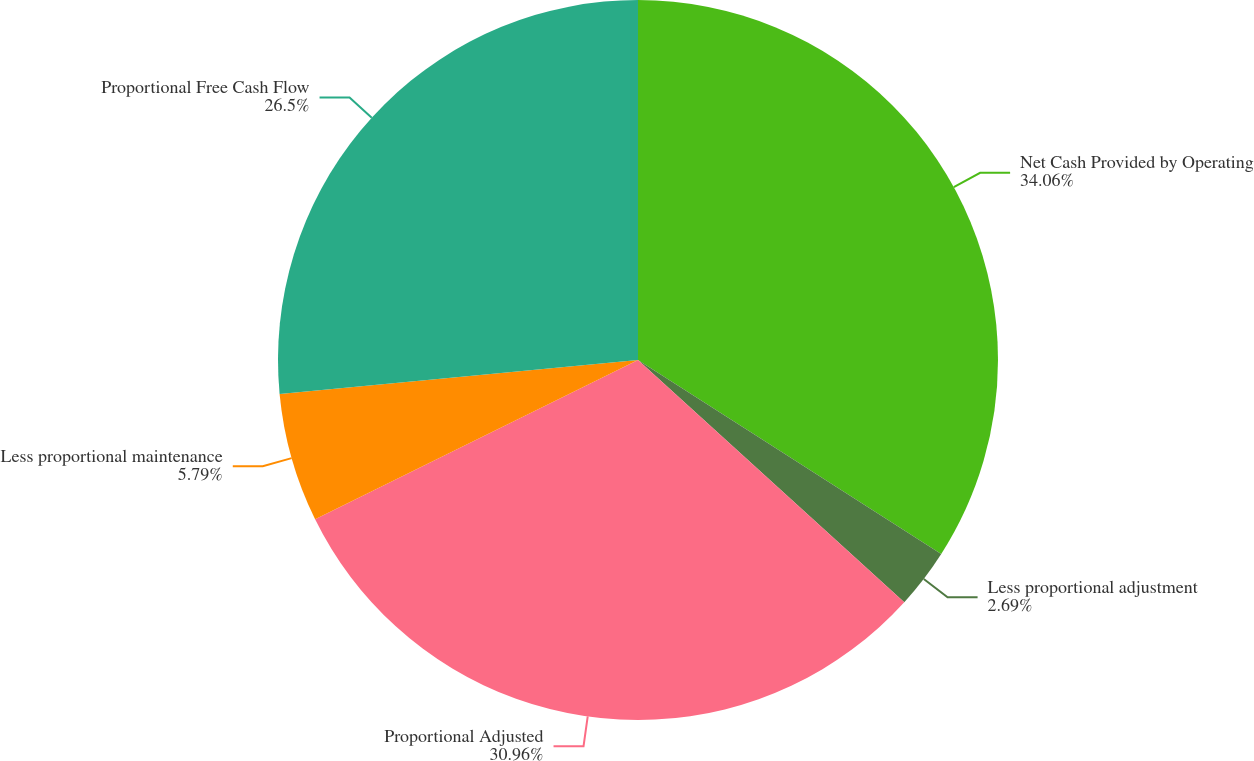<chart> <loc_0><loc_0><loc_500><loc_500><pie_chart><fcel>Net Cash Provided by Operating<fcel>Less proportional adjustment<fcel>Proportional Adjusted<fcel>Less proportional maintenance<fcel>Proportional Free Cash Flow<nl><fcel>34.06%<fcel>2.69%<fcel>30.96%<fcel>5.79%<fcel>26.5%<nl></chart> 